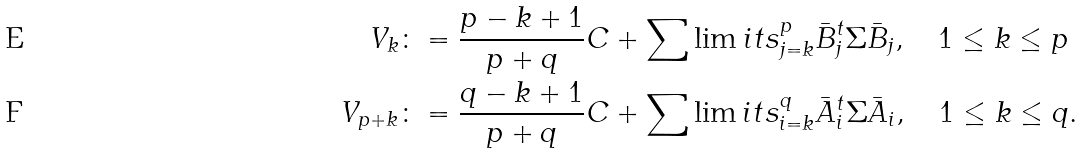Convert formula to latex. <formula><loc_0><loc_0><loc_500><loc_500>V _ { k } & \colon = \frac { p - k + 1 } { p + q } C + \sum \lim i t s _ { j = k } ^ { p } \bar { B } _ { j } ^ { t } \Sigma \bar { B } _ { j } , \quad 1 \leq k \leq p \\ V _ { p + k } & \colon = \frac { q - k + 1 } { p + q } C + \sum \lim i t s _ { i = k } ^ { q } \bar { A } _ { i } ^ { t } \Sigma \bar { A } _ { i } , \quad 1 \leq k \leq q .</formula> 